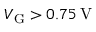<formula> <loc_0><loc_0><loc_500><loc_500>V _ { G } > 0 . 7 5 \, V</formula> 